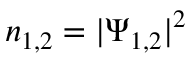<formula> <loc_0><loc_0><loc_500><loc_500>n _ { 1 , 2 } = | \Psi _ { 1 , 2 } | ^ { 2 }</formula> 